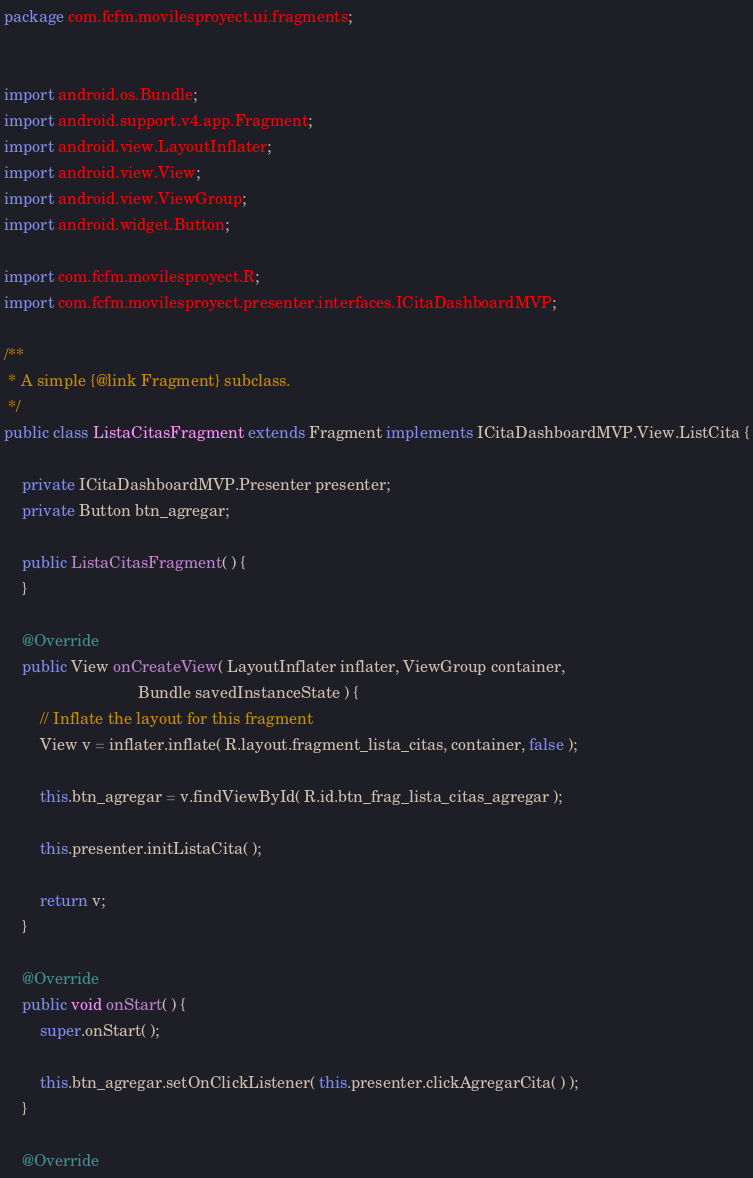Convert code to text. <code><loc_0><loc_0><loc_500><loc_500><_Java_>package com.fcfm.movilesproyect.ui.fragments;


import android.os.Bundle;
import android.support.v4.app.Fragment;
import android.view.LayoutInflater;
import android.view.View;
import android.view.ViewGroup;
import android.widget.Button;

import com.fcfm.movilesproyect.R;
import com.fcfm.movilesproyect.presenter.interfaces.ICitaDashboardMVP;

/**
 * A simple {@link Fragment} subclass.
 */
public class ListaCitasFragment extends Fragment implements ICitaDashboardMVP.View.ListCita {
	
	private ICitaDashboardMVP.Presenter presenter;
	private Button btn_agregar;
	
	public ListaCitasFragment( ) {
	}
	
	@Override
	public View onCreateView( LayoutInflater inflater, ViewGroup container,
	                          Bundle savedInstanceState ) {
		// Inflate the layout for this fragment
		View v = inflater.inflate( R.layout.fragment_lista_citas, container, false );
		
		this.btn_agregar = v.findViewById( R.id.btn_frag_lista_citas_agregar );
		
		this.presenter.initListaCita( );
		
		return v;
	}
	
	@Override
	public void onStart( ) {
		super.onStart( );
		
		this.btn_agregar.setOnClickListener( this.presenter.clickAgregarCita( ) );
	}
	
	@Override</code> 